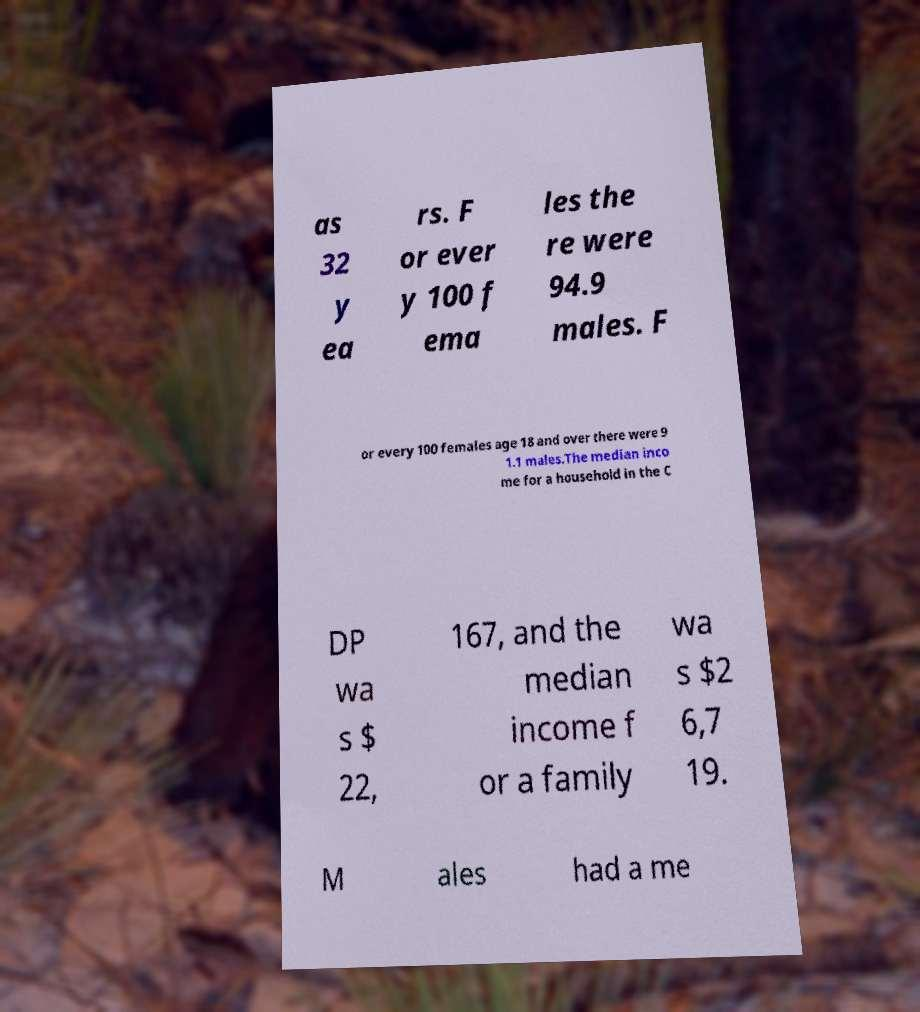Please read and relay the text visible in this image. What does it say? as 32 y ea rs. F or ever y 100 f ema les the re were 94.9 males. F or every 100 females age 18 and over there were 9 1.1 males.The median inco me for a household in the C DP wa s $ 22, 167, and the median income f or a family wa s $2 6,7 19. M ales had a me 